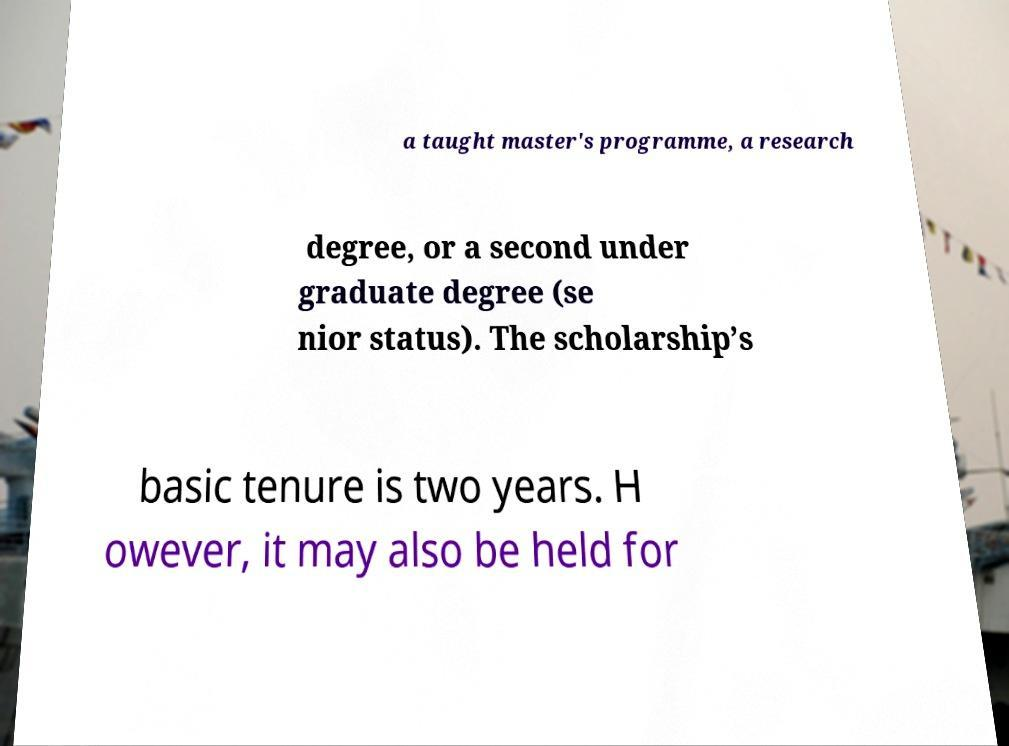Can you accurately transcribe the text from the provided image for me? a taught master's programme, a research degree, or a second under graduate degree (se nior status). The scholarship’s basic tenure is two years. H owever, it may also be held for 